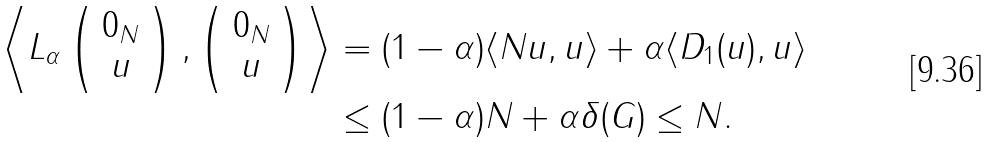Convert formula to latex. <formula><loc_0><loc_0><loc_500><loc_500>\left \langle L _ { \alpha } \left ( \begin{array} { c } 0 _ { N } \\ u \end{array} \right ) , \left ( \begin{array} { c } 0 _ { N } \\ u \end{array} \right ) \right \rangle & = ( 1 - \alpha ) \langle N u , u \rangle + \alpha \langle D _ { 1 } ( u ) , u \rangle \\ & \leq ( 1 - \alpha ) N + \alpha \delta ( G ) \leq N .</formula> 